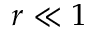<formula> <loc_0><loc_0><loc_500><loc_500>r \ll 1</formula> 